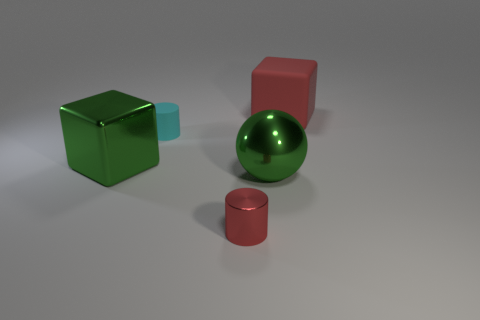Add 2 large red rubber cubes. How many large red rubber cubes exist? 3 Add 3 tiny metal cylinders. How many objects exist? 8 Subtract all red cubes. How many cubes are left? 1 Subtract 0 green cylinders. How many objects are left? 5 Subtract all spheres. How many objects are left? 4 Subtract 1 spheres. How many spheres are left? 0 Subtract all yellow cubes. Subtract all red cylinders. How many cubes are left? 2 Subtract all red blocks. How many gray cylinders are left? 0 Subtract all large red things. Subtract all green shiny cubes. How many objects are left? 3 Add 3 large green metal blocks. How many large green metal blocks are left? 4 